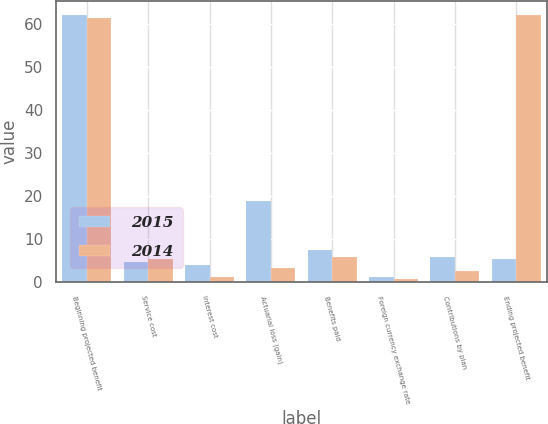<chart> <loc_0><loc_0><loc_500><loc_500><stacked_bar_chart><ecel><fcel>Beginning projected benefit<fcel>Service cost<fcel>Interest cost<fcel>Actuarial loss (gain)<fcel>Benefits paid<fcel>Foreign currency exchange rate<fcel>Contributions by plan<fcel>Ending projected benefit<nl><fcel>2015<fcel>62.2<fcel>4.6<fcel>3.9<fcel>18.8<fcel>7.5<fcel>1.2<fcel>5.9<fcel>5.4<nl><fcel>2014<fcel>61.5<fcel>5.4<fcel>1.1<fcel>3.2<fcel>5.9<fcel>0.8<fcel>2.5<fcel>62.2<nl></chart> 